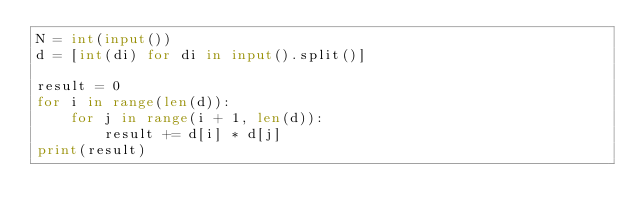<code> <loc_0><loc_0><loc_500><loc_500><_Python_>N = int(input())
d = [int(di) for di in input().split()]

result = 0
for i in range(len(d)):
    for j in range(i + 1, len(d)):
        result += d[i] * d[j]
print(result)
</code> 